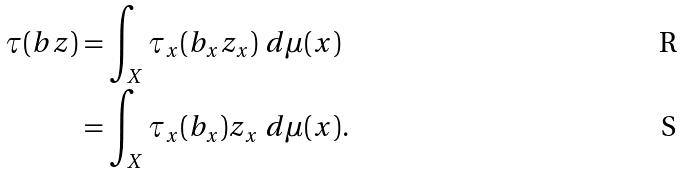Convert formula to latex. <formula><loc_0><loc_0><loc_500><loc_500>\tau ( b z ) & = \int _ { X } \tau _ { x } ( b _ { x } z _ { x } ) \ d \mu ( x ) \\ & = \int _ { X } \tau _ { x } ( b _ { x } ) z _ { x } \ d \mu ( x ) .</formula> 